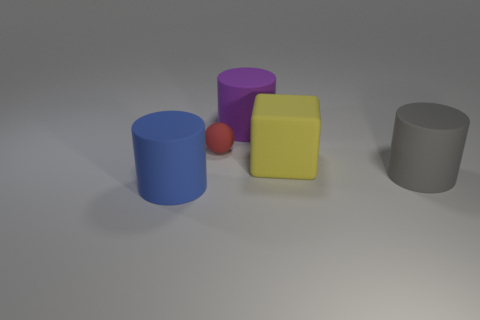Do the large thing left of the small red ball and the red object have the same shape?
Provide a succinct answer. No. There is a cylinder that is on the left side of the big purple rubber object; what is its material?
Provide a short and direct response. Rubber. Is there another large yellow ball made of the same material as the ball?
Your answer should be very brief. No. The yellow thing has what size?
Make the answer very short. Large. What number of purple objects are either matte balls or large matte blocks?
Provide a succinct answer. 0. What number of big gray things are the same shape as the small red object?
Give a very brief answer. 0. How many yellow objects have the same size as the yellow rubber cube?
Make the answer very short. 0. What is the color of the large thing that is to the left of the big purple cylinder?
Offer a very short reply. Blue. Are there more rubber cylinders left of the purple matte thing than big cyan matte things?
Provide a succinct answer. Yes. What color is the tiny sphere?
Your response must be concise. Red. 